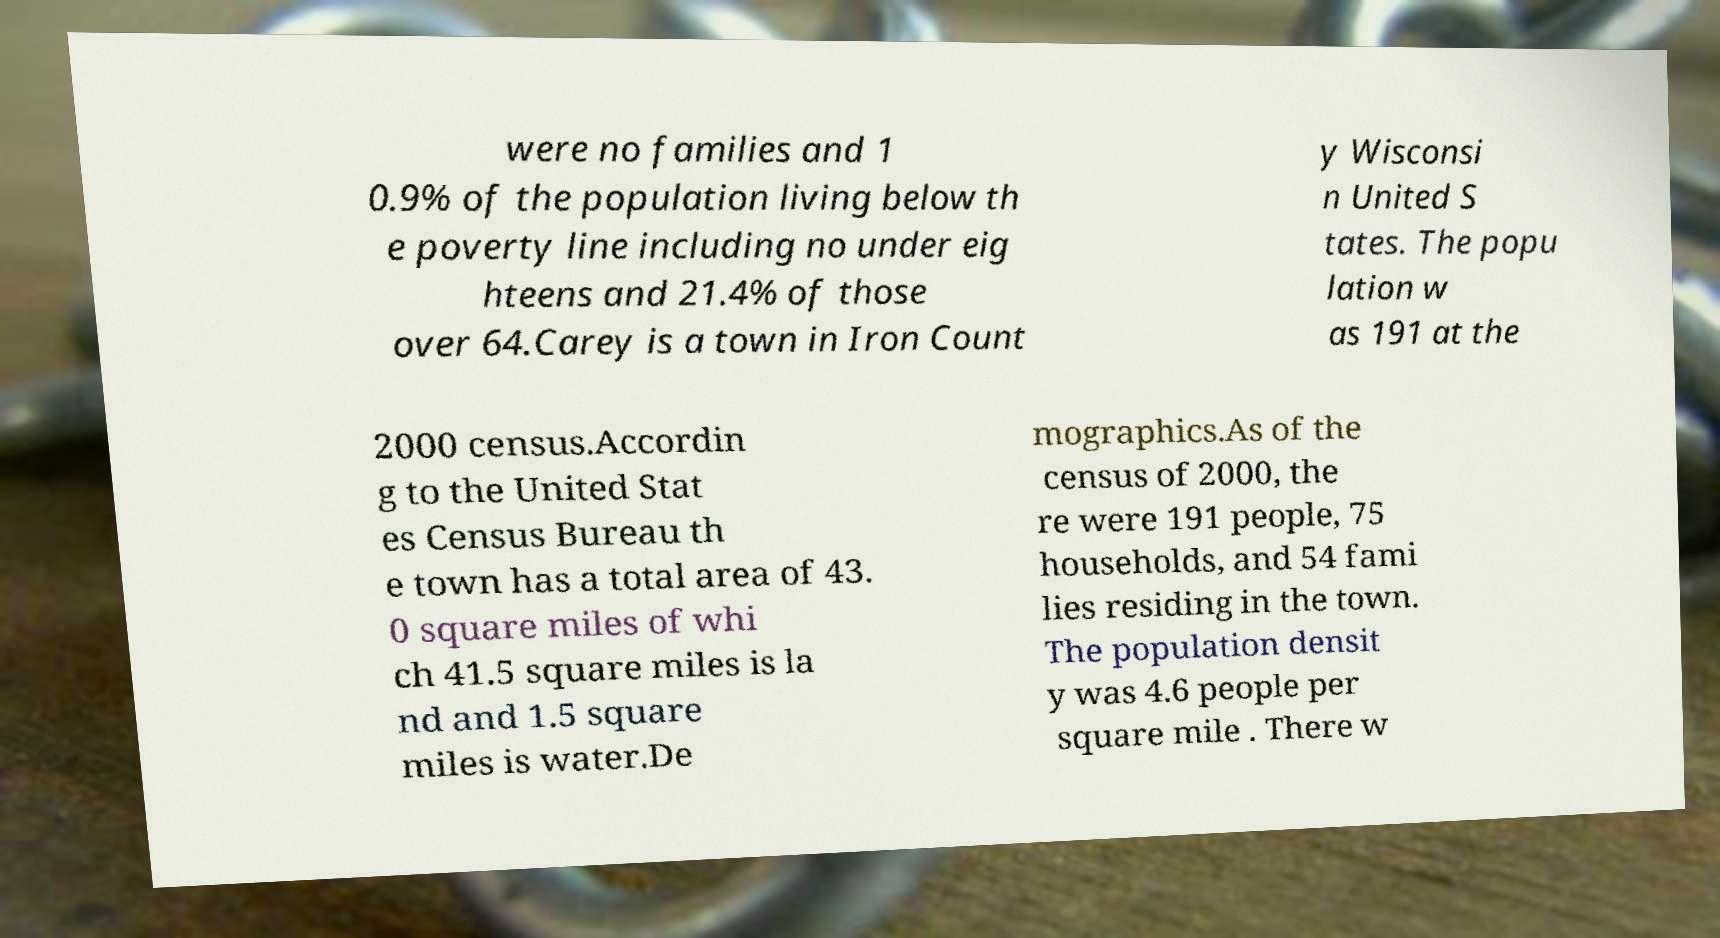Can you accurately transcribe the text from the provided image for me? were no families and 1 0.9% of the population living below th e poverty line including no under eig hteens and 21.4% of those over 64.Carey is a town in Iron Count y Wisconsi n United S tates. The popu lation w as 191 at the 2000 census.Accordin g to the United Stat es Census Bureau th e town has a total area of 43. 0 square miles of whi ch 41.5 square miles is la nd and 1.5 square miles is water.De mographics.As of the census of 2000, the re were 191 people, 75 households, and 54 fami lies residing in the town. The population densit y was 4.6 people per square mile . There w 